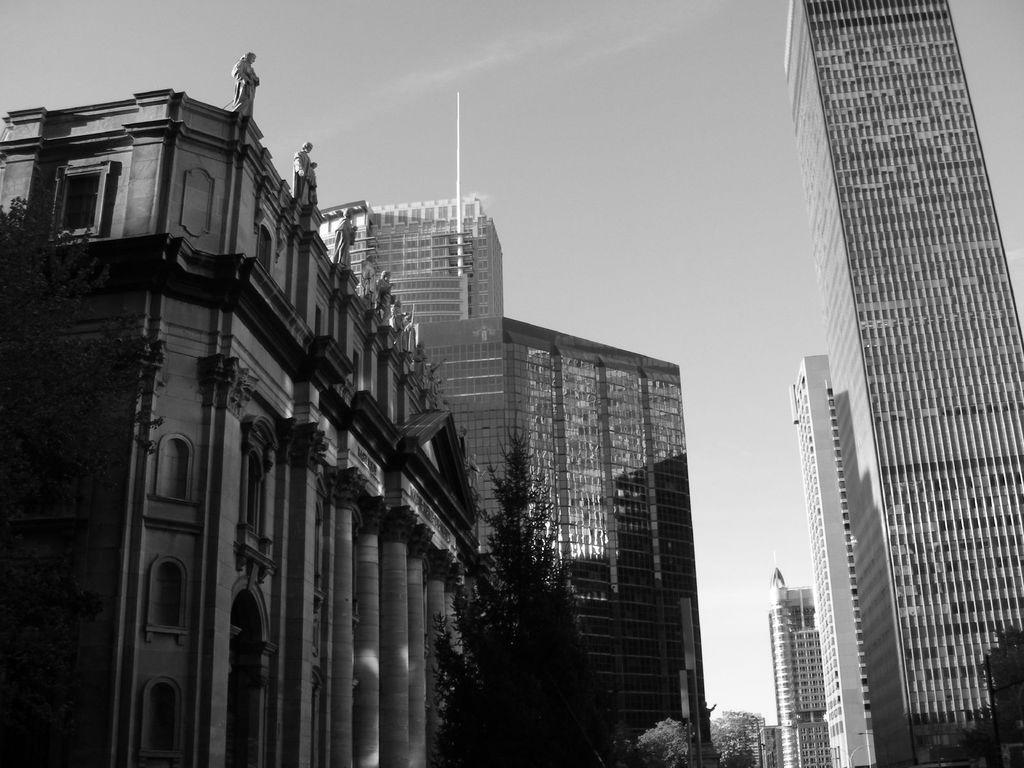Could you give a brief overview of what you see in this image? In this picture we can describe about the view of the buildings in the middle of the image. On the left side of the image we can see old building with some big pillar and arch windows. On the top we can see some status are placed. 